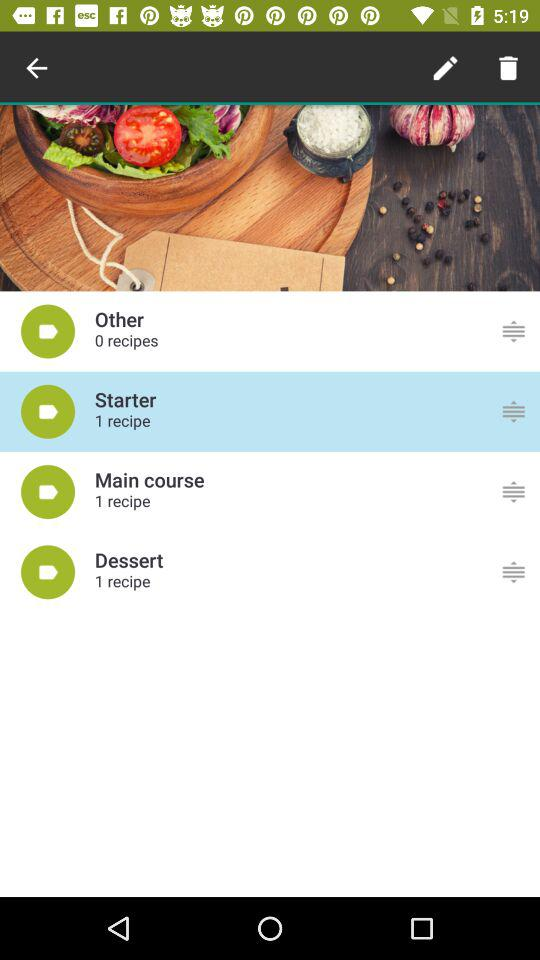What is the number of recipes in the starter? The number of recipes in the starter is 1. 